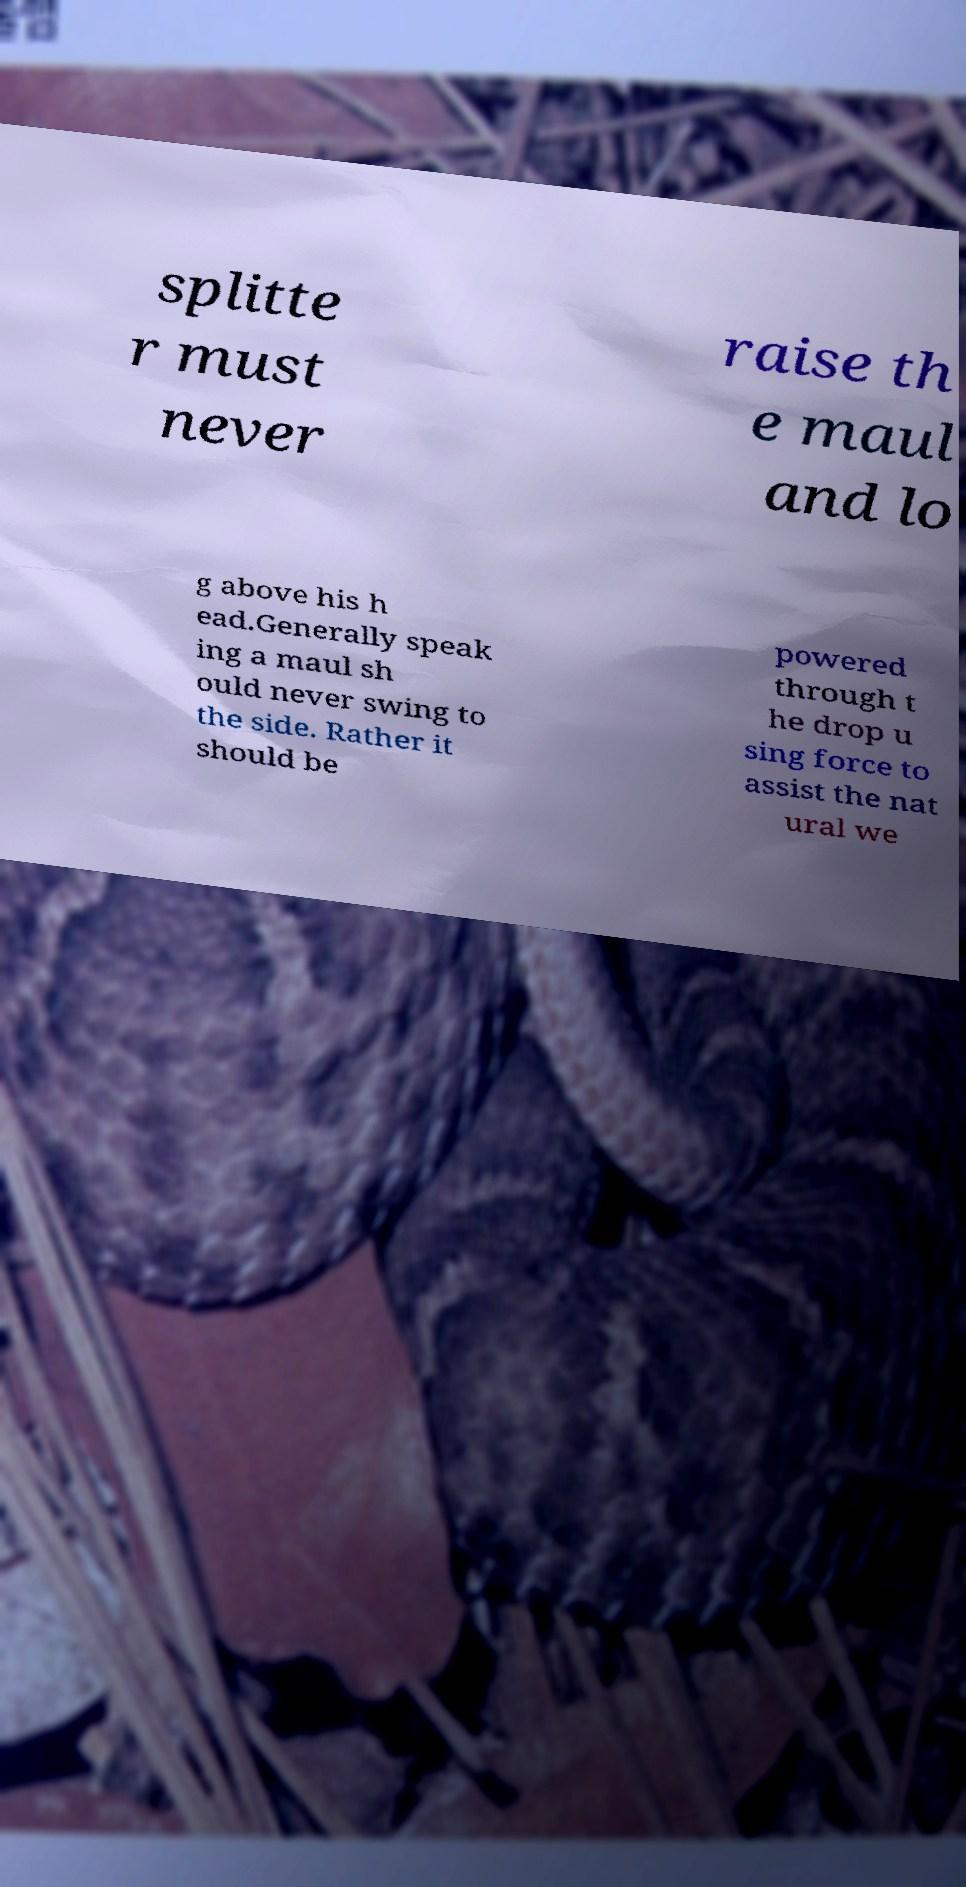Can you accurately transcribe the text from the provided image for me? splitte r must never raise th e maul and lo g above his h ead.Generally speak ing a maul sh ould never swing to the side. Rather it should be powered through t he drop u sing force to assist the nat ural we 